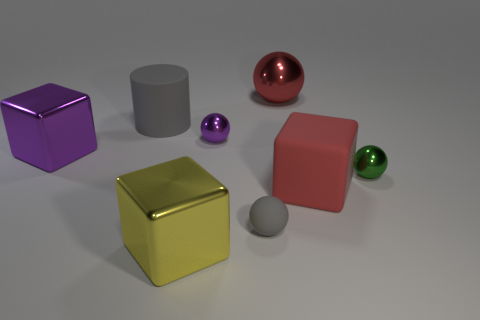Subtract all large metal cubes. How many cubes are left? 1 Subtract all red spheres. How many spheres are left? 3 Add 2 green blocks. How many objects exist? 10 Subtract 1 blocks. How many blocks are left? 2 Subtract all cylinders. How many objects are left? 7 Subtract all big red metallic things. Subtract all big yellow metallic things. How many objects are left? 6 Add 5 small green spheres. How many small green spheres are left? 6 Add 5 gray rubber objects. How many gray rubber objects exist? 7 Subtract 0 brown cylinders. How many objects are left? 8 Subtract all yellow spheres. Subtract all green cylinders. How many spheres are left? 4 